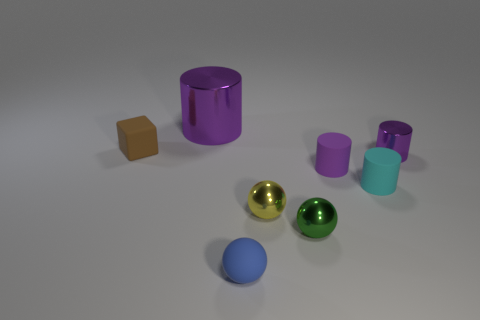Subtract all gray spheres. How many purple cylinders are left? 3 Subtract all gray cylinders. Subtract all brown blocks. How many cylinders are left? 4 Add 2 small blue matte objects. How many objects exist? 10 Subtract all cubes. How many objects are left? 7 Add 2 big purple shiny things. How many big purple shiny things are left? 3 Add 4 large cyan metallic cubes. How many large cyan metallic cubes exist? 4 Subtract 0 brown cylinders. How many objects are left? 8 Subtract all yellow balls. Subtract all small purple metallic cylinders. How many objects are left? 6 